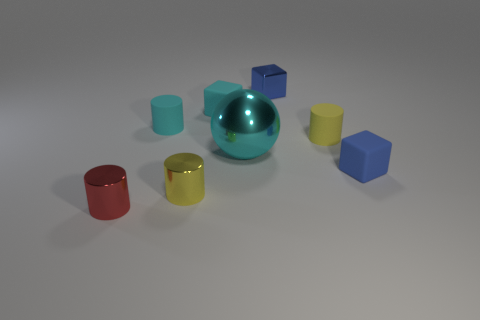There is a metal thing that is the same shape as the blue rubber object; what is its color?
Make the answer very short. Blue. Is there any other thing that is the same color as the large ball?
Offer a very short reply. Yes. How many other objects are there of the same material as the tiny red thing?
Offer a terse response. 3. The sphere is what size?
Offer a very short reply. Large. Are there any matte objects of the same shape as the small yellow shiny object?
Your answer should be very brief. Yes. What number of things are small brown shiny spheres or small metallic objects left of the tiny cyan matte cube?
Keep it short and to the point. 2. What color is the matte cylinder that is right of the big cyan object?
Your answer should be very brief. Yellow. There is a metal cylinder to the left of the cyan rubber cylinder; is its size the same as the yellow object that is to the right of the metallic cube?
Offer a terse response. Yes. Are there any blue matte objects of the same size as the red metallic object?
Your response must be concise. Yes. How many rubber cylinders are in front of the cylinder on the right side of the cyan matte block?
Offer a terse response. 0. 